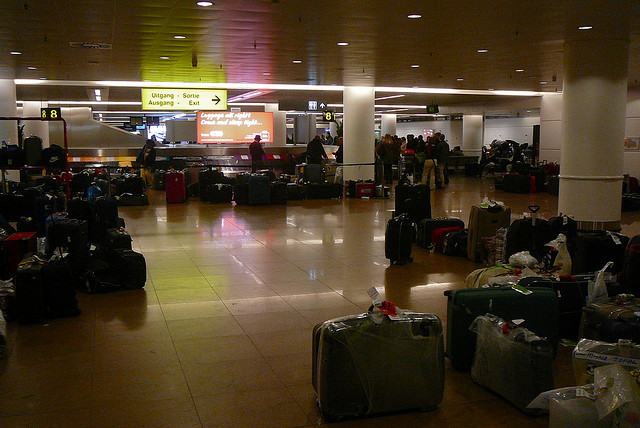Read and extract the text from this image. 8 